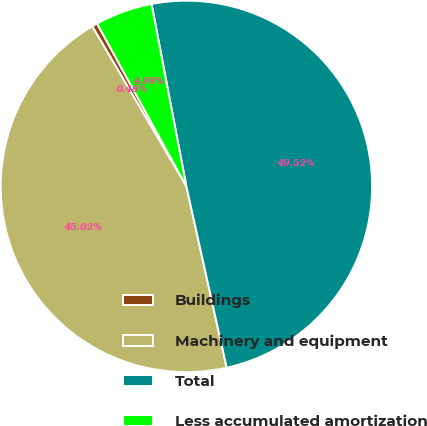<chart> <loc_0><loc_0><loc_500><loc_500><pie_chart><fcel>Buildings<fcel>Machinery and equipment<fcel>Total<fcel>Less accumulated amortization<nl><fcel>0.48%<fcel>45.02%<fcel>49.52%<fcel>4.98%<nl></chart> 